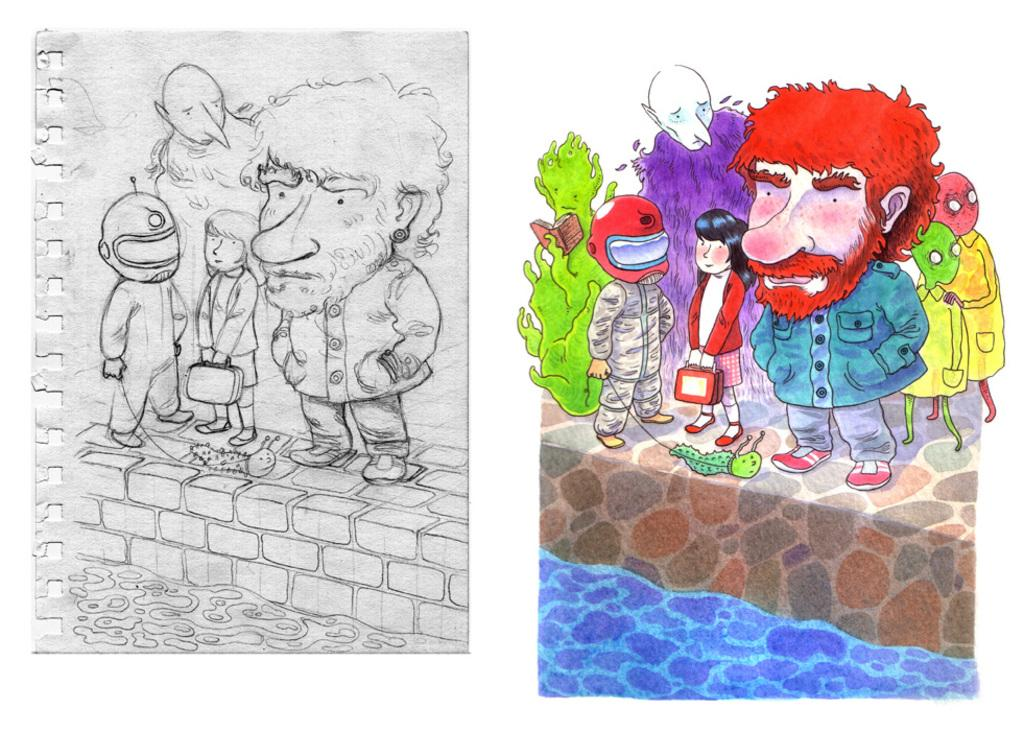What type of artwork is visible in the image? There is a painting and a drawing on paper in the image. What other artistic elements can be seen in the image? Cartoons are present in the image. How do the bells control the movement of the cartoons in the image? There are no bells present in the image, and therefore they cannot control the movement of the cartoons. 